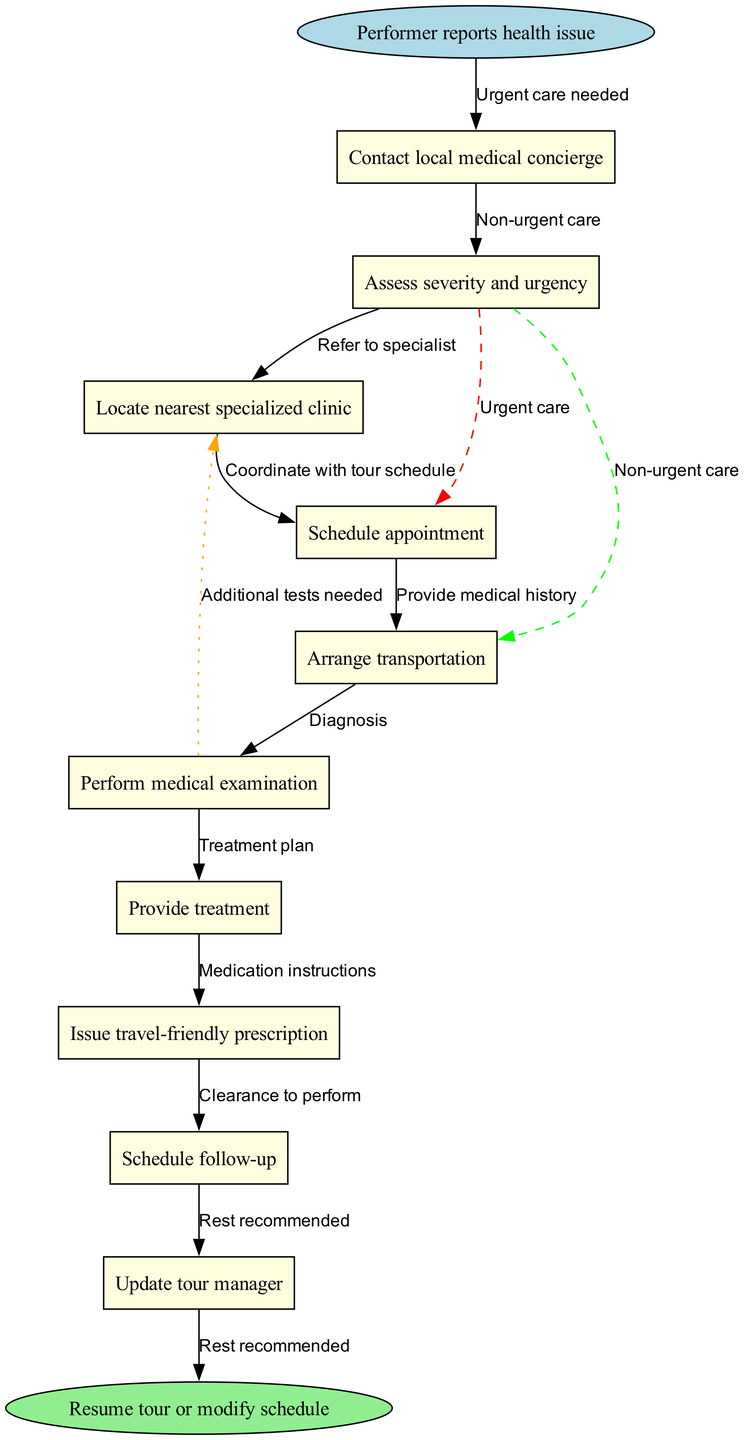What is the first step that occurs in the pathway? The diagram starts with the node labeled "Performer reports health issue," which indicates the initial action that triggers the clinical pathway.
Answer: Performer reports health issue How many nodes are there in total? The diagram contains one start node, several intermediate nodes (10 total), and one end node, which adds up to 12 nodes overall.
Answer: 12 What step follows after "Assess severity and urgency"? According to the edge connections in the diagram, the next step after "Assess severity and urgency" is "Locate nearest specialized clinic."
Answer: Locate nearest specialized clinic What action needs to be taken for urgent care? The diagram shows that urgent care requires the action "Schedule appointment" as indicated by the edge leading from "Assess severity and urgency."
Answer: Schedule appointment What do you need to provide to the clinic during the appointment? The node "Provide medical history" illustrates that sharing medical history is essential during the appointment at the specialized clinic.
Answer: Provide medical history If the diagnosis recommends rest, what is the next step in the pathway? If the diagnosis recommends rest, according to the pathway's flow, the next step would be issuing a clearance to perform or potentially modifying the schedule, which points towards the end of the pathway.
Answer: Clearance to perform What happens after the "Perform medical examination"? After "Perform medical examination," the next node indicates that the practitioner will provide a "Diagnosis," which follows sequentially in the clinical pathway.
Answer: Diagnosis How is transportation arranged in the process? The diagram notes that after "Locate nearest specialized clinic," there is an action of "Arrange transportation," showing the importance of organizing transport to the clinic.
Answer: Arrange transportation What type of prescription is issued at the end of the pathway? The pathway specifies that a "travel-friendly prescription" is provided, which indicates that the prescription is designed for the travel needs of the performer.
Answer: Travel-friendly prescription 